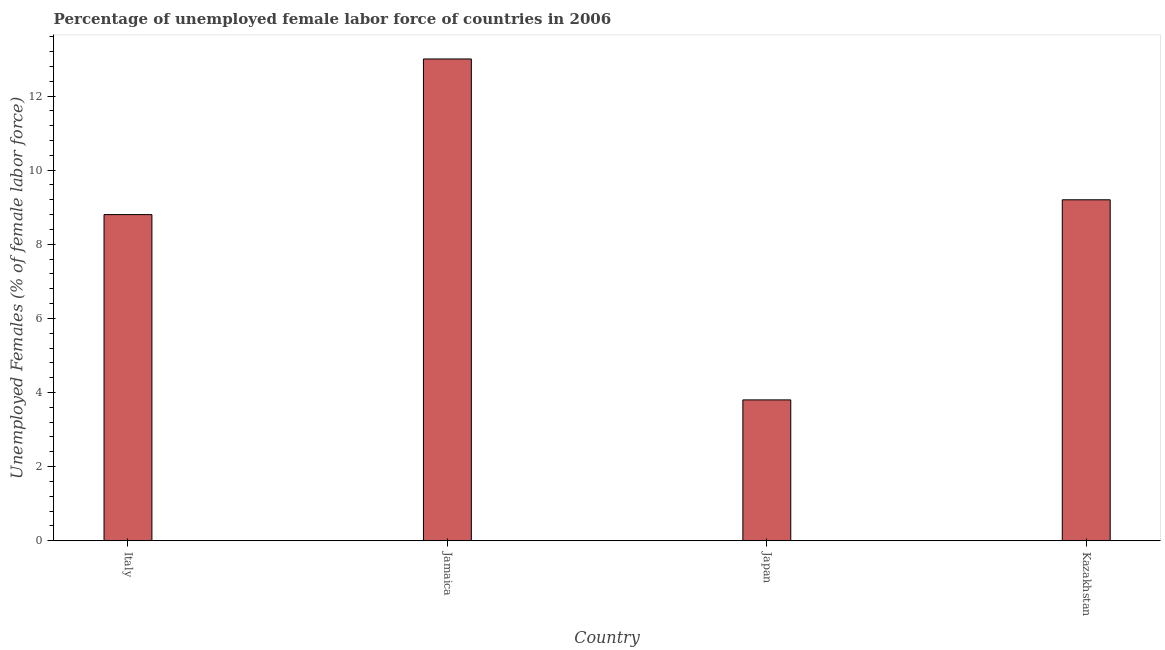Does the graph contain grids?
Offer a very short reply. No. What is the title of the graph?
Ensure brevity in your answer.  Percentage of unemployed female labor force of countries in 2006. What is the label or title of the Y-axis?
Provide a short and direct response. Unemployed Females (% of female labor force). What is the total unemployed female labour force in Japan?
Provide a succinct answer. 3.8. Across all countries, what is the minimum total unemployed female labour force?
Your answer should be very brief. 3.8. In which country was the total unemployed female labour force maximum?
Provide a short and direct response. Jamaica. What is the sum of the total unemployed female labour force?
Provide a succinct answer. 34.8. What is the average total unemployed female labour force per country?
Ensure brevity in your answer.  8.7. What is the median total unemployed female labour force?
Your answer should be compact. 9. In how many countries, is the total unemployed female labour force greater than 3.2 %?
Keep it short and to the point. 4. What is the ratio of the total unemployed female labour force in Jamaica to that in Japan?
Your response must be concise. 3.42. Is the difference between the total unemployed female labour force in Italy and Jamaica greater than the difference between any two countries?
Ensure brevity in your answer.  No. What is the difference between the highest and the second highest total unemployed female labour force?
Your response must be concise. 3.8. In how many countries, is the total unemployed female labour force greater than the average total unemployed female labour force taken over all countries?
Offer a very short reply. 3. Are all the bars in the graph horizontal?
Give a very brief answer. No. What is the Unemployed Females (% of female labor force) of Italy?
Keep it short and to the point. 8.8. What is the Unemployed Females (% of female labor force) in Japan?
Give a very brief answer. 3.8. What is the Unemployed Females (% of female labor force) in Kazakhstan?
Give a very brief answer. 9.2. What is the difference between the Unemployed Females (% of female labor force) in Italy and Japan?
Keep it short and to the point. 5. What is the difference between the Unemployed Females (% of female labor force) in Italy and Kazakhstan?
Ensure brevity in your answer.  -0.4. What is the difference between the Unemployed Females (% of female labor force) in Jamaica and Kazakhstan?
Offer a terse response. 3.8. What is the ratio of the Unemployed Females (% of female labor force) in Italy to that in Jamaica?
Your answer should be compact. 0.68. What is the ratio of the Unemployed Females (% of female labor force) in Italy to that in Japan?
Your response must be concise. 2.32. What is the ratio of the Unemployed Females (% of female labor force) in Jamaica to that in Japan?
Your response must be concise. 3.42. What is the ratio of the Unemployed Females (% of female labor force) in Jamaica to that in Kazakhstan?
Ensure brevity in your answer.  1.41. What is the ratio of the Unemployed Females (% of female labor force) in Japan to that in Kazakhstan?
Make the answer very short. 0.41. 